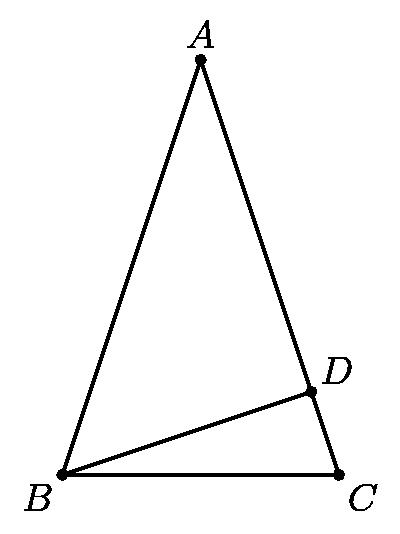Consider all triangles $ABC$ satisfying the following conditions: $AB = AC$, $D$ is a point on $\overline{AC}$ for which $\overline{BD} \perp \overline{AC}$, $AD$ and $CD$ are integers, and $BD^2 = 57$. Among all such triangles, the smallest possible value of $AC$ is The smallest possible value of $AC$ in such triangles is 11. This calculation involves considering Pythagoras' theorem applied to triangle ADB, exploiting the properties of the isosceles triangle and leveraging the known integral sides along with the condition that $BD^2 = 57$. Specifically, finding integral values that satisfy these conditions leads to the conclusion that the length of $AC = 11$ offers the minimal configuration adhering to all given constraints. 